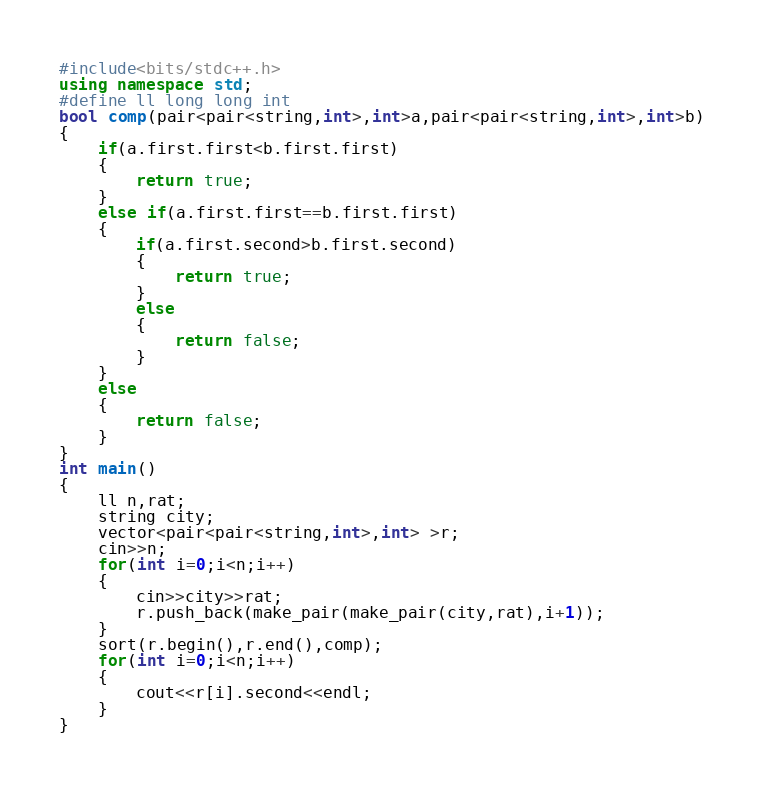Convert code to text. <code><loc_0><loc_0><loc_500><loc_500><_C++_>#include<bits/stdc++.h>
using namespace std;
#define ll long long int
bool comp(pair<pair<string,int>,int>a,pair<pair<string,int>,int>b)
{
	if(a.first.first<b.first.first)
	{
		return true;
	}
	else if(a.first.first==b.first.first)
	{
		if(a.first.second>b.first.second)
		{
			return true;
		}
		else
		{
			return false;
		}
	}
	else
	{
		return false;
	}
}
int main()
{
	ll n,rat;
	string city;
	vector<pair<pair<string,int>,int> >r;
	cin>>n;
	for(int i=0;i<n;i++)
	{
		cin>>city>>rat;
		r.push_back(make_pair(make_pair(city,rat),i+1));
	}
	sort(r.begin(),r.end(),comp);
	for(int i=0;i<n;i++)
	{
		cout<<r[i].second<<endl;
	}
}
</code> 